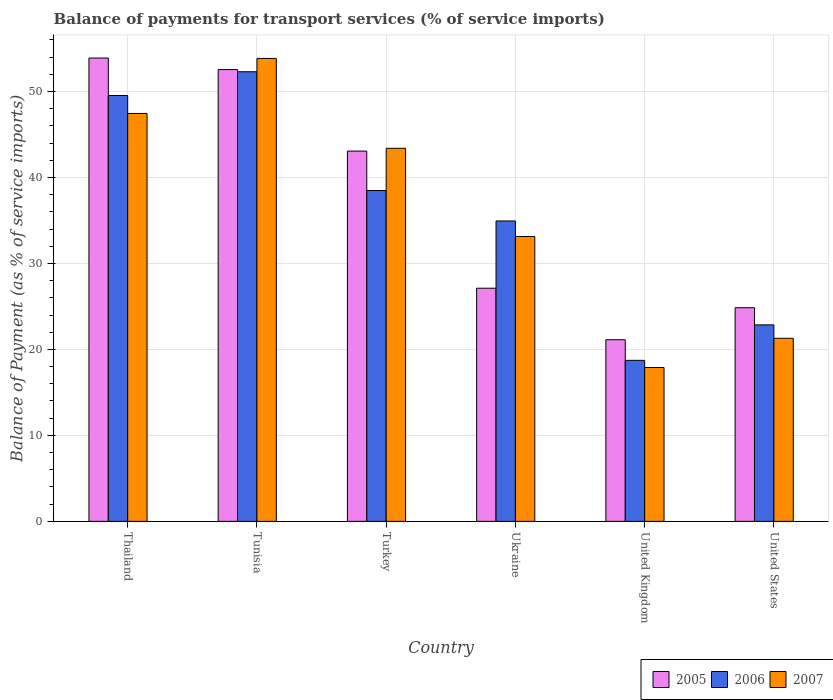How many different coloured bars are there?
Ensure brevity in your answer.  3. How many groups of bars are there?
Your response must be concise. 6. Are the number of bars per tick equal to the number of legend labels?
Your answer should be very brief. Yes. How many bars are there on the 3rd tick from the left?
Provide a short and direct response. 3. How many bars are there on the 6th tick from the right?
Your answer should be very brief. 3. What is the label of the 3rd group of bars from the left?
Your response must be concise. Turkey. In how many cases, is the number of bars for a given country not equal to the number of legend labels?
Your response must be concise. 0. What is the balance of payments for transport services in 2007 in United States?
Provide a short and direct response. 21.29. Across all countries, what is the maximum balance of payments for transport services in 2007?
Ensure brevity in your answer.  53.84. Across all countries, what is the minimum balance of payments for transport services in 2006?
Provide a short and direct response. 18.73. In which country was the balance of payments for transport services in 2006 maximum?
Your answer should be compact. Tunisia. In which country was the balance of payments for transport services in 2007 minimum?
Provide a short and direct response. United Kingdom. What is the total balance of payments for transport services in 2006 in the graph?
Your response must be concise. 216.81. What is the difference between the balance of payments for transport services in 2007 in Turkey and that in United States?
Ensure brevity in your answer.  22.1. What is the difference between the balance of payments for transport services in 2007 in Turkey and the balance of payments for transport services in 2006 in Ukraine?
Provide a short and direct response. 8.45. What is the average balance of payments for transport services in 2006 per country?
Ensure brevity in your answer.  36.13. What is the difference between the balance of payments for transport services of/in 2006 and balance of payments for transport services of/in 2005 in Ukraine?
Provide a succinct answer. 7.82. In how many countries, is the balance of payments for transport services in 2006 greater than 40 %?
Your answer should be very brief. 2. What is the ratio of the balance of payments for transport services in 2005 in Thailand to that in Turkey?
Provide a succinct answer. 1.25. Is the difference between the balance of payments for transport services in 2006 in Thailand and Ukraine greater than the difference between the balance of payments for transport services in 2005 in Thailand and Ukraine?
Your answer should be very brief. No. What is the difference between the highest and the second highest balance of payments for transport services in 2006?
Offer a terse response. -2.76. What is the difference between the highest and the lowest balance of payments for transport services in 2005?
Provide a succinct answer. 32.76. What does the 1st bar from the right in Thailand represents?
Your response must be concise. 2007. Is it the case that in every country, the sum of the balance of payments for transport services in 2005 and balance of payments for transport services in 2007 is greater than the balance of payments for transport services in 2006?
Provide a succinct answer. Yes. How many bars are there?
Ensure brevity in your answer.  18. Are all the bars in the graph horizontal?
Make the answer very short. No. Are the values on the major ticks of Y-axis written in scientific E-notation?
Give a very brief answer. No. How are the legend labels stacked?
Offer a very short reply. Horizontal. What is the title of the graph?
Offer a very short reply. Balance of payments for transport services (% of service imports). What is the label or title of the X-axis?
Provide a succinct answer. Country. What is the label or title of the Y-axis?
Offer a terse response. Balance of Payment (as % of service imports). What is the Balance of Payment (as % of service imports) of 2005 in Thailand?
Your response must be concise. 53.88. What is the Balance of Payment (as % of service imports) in 2006 in Thailand?
Give a very brief answer. 49.53. What is the Balance of Payment (as % of service imports) of 2007 in Thailand?
Make the answer very short. 47.44. What is the Balance of Payment (as % of service imports) of 2005 in Tunisia?
Provide a short and direct response. 52.54. What is the Balance of Payment (as % of service imports) of 2006 in Tunisia?
Provide a short and direct response. 52.29. What is the Balance of Payment (as % of service imports) of 2007 in Tunisia?
Make the answer very short. 53.84. What is the Balance of Payment (as % of service imports) of 2005 in Turkey?
Offer a very short reply. 43.06. What is the Balance of Payment (as % of service imports) of 2006 in Turkey?
Keep it short and to the point. 38.47. What is the Balance of Payment (as % of service imports) of 2007 in Turkey?
Your answer should be compact. 43.39. What is the Balance of Payment (as % of service imports) in 2005 in Ukraine?
Your response must be concise. 27.12. What is the Balance of Payment (as % of service imports) in 2006 in Ukraine?
Your answer should be very brief. 34.94. What is the Balance of Payment (as % of service imports) of 2007 in Ukraine?
Keep it short and to the point. 33.13. What is the Balance of Payment (as % of service imports) in 2005 in United Kingdom?
Offer a very short reply. 21.12. What is the Balance of Payment (as % of service imports) of 2006 in United Kingdom?
Your answer should be very brief. 18.73. What is the Balance of Payment (as % of service imports) in 2007 in United Kingdom?
Your response must be concise. 17.89. What is the Balance of Payment (as % of service imports) in 2005 in United States?
Your response must be concise. 24.85. What is the Balance of Payment (as % of service imports) in 2006 in United States?
Ensure brevity in your answer.  22.85. What is the Balance of Payment (as % of service imports) of 2007 in United States?
Keep it short and to the point. 21.29. Across all countries, what is the maximum Balance of Payment (as % of service imports) of 2005?
Make the answer very short. 53.88. Across all countries, what is the maximum Balance of Payment (as % of service imports) of 2006?
Your answer should be compact. 52.29. Across all countries, what is the maximum Balance of Payment (as % of service imports) of 2007?
Ensure brevity in your answer.  53.84. Across all countries, what is the minimum Balance of Payment (as % of service imports) in 2005?
Your answer should be compact. 21.12. Across all countries, what is the minimum Balance of Payment (as % of service imports) in 2006?
Your answer should be very brief. 18.73. Across all countries, what is the minimum Balance of Payment (as % of service imports) in 2007?
Provide a succinct answer. 17.89. What is the total Balance of Payment (as % of service imports) in 2005 in the graph?
Give a very brief answer. 222.57. What is the total Balance of Payment (as % of service imports) in 2006 in the graph?
Keep it short and to the point. 216.81. What is the total Balance of Payment (as % of service imports) in 2007 in the graph?
Your answer should be very brief. 216.99. What is the difference between the Balance of Payment (as % of service imports) of 2005 in Thailand and that in Tunisia?
Your response must be concise. 1.34. What is the difference between the Balance of Payment (as % of service imports) of 2006 in Thailand and that in Tunisia?
Ensure brevity in your answer.  -2.76. What is the difference between the Balance of Payment (as % of service imports) in 2007 in Thailand and that in Tunisia?
Your response must be concise. -6.4. What is the difference between the Balance of Payment (as % of service imports) of 2005 in Thailand and that in Turkey?
Provide a succinct answer. 10.82. What is the difference between the Balance of Payment (as % of service imports) in 2006 in Thailand and that in Turkey?
Your answer should be compact. 11.05. What is the difference between the Balance of Payment (as % of service imports) of 2007 in Thailand and that in Turkey?
Your answer should be compact. 4.05. What is the difference between the Balance of Payment (as % of service imports) of 2005 in Thailand and that in Ukraine?
Your answer should be compact. 26.77. What is the difference between the Balance of Payment (as % of service imports) of 2006 in Thailand and that in Ukraine?
Provide a succinct answer. 14.59. What is the difference between the Balance of Payment (as % of service imports) of 2007 in Thailand and that in Ukraine?
Your response must be concise. 14.31. What is the difference between the Balance of Payment (as % of service imports) in 2005 in Thailand and that in United Kingdom?
Your answer should be compact. 32.76. What is the difference between the Balance of Payment (as % of service imports) in 2006 in Thailand and that in United Kingdom?
Provide a succinct answer. 30.8. What is the difference between the Balance of Payment (as % of service imports) in 2007 in Thailand and that in United Kingdom?
Provide a succinct answer. 29.55. What is the difference between the Balance of Payment (as % of service imports) in 2005 in Thailand and that in United States?
Give a very brief answer. 29.04. What is the difference between the Balance of Payment (as % of service imports) in 2006 in Thailand and that in United States?
Offer a very short reply. 26.68. What is the difference between the Balance of Payment (as % of service imports) of 2007 in Thailand and that in United States?
Your response must be concise. 26.15. What is the difference between the Balance of Payment (as % of service imports) in 2005 in Tunisia and that in Turkey?
Provide a succinct answer. 9.48. What is the difference between the Balance of Payment (as % of service imports) of 2006 in Tunisia and that in Turkey?
Offer a very short reply. 13.82. What is the difference between the Balance of Payment (as % of service imports) of 2007 in Tunisia and that in Turkey?
Keep it short and to the point. 10.45. What is the difference between the Balance of Payment (as % of service imports) in 2005 in Tunisia and that in Ukraine?
Provide a short and direct response. 25.43. What is the difference between the Balance of Payment (as % of service imports) in 2006 in Tunisia and that in Ukraine?
Your answer should be very brief. 17.35. What is the difference between the Balance of Payment (as % of service imports) in 2007 in Tunisia and that in Ukraine?
Ensure brevity in your answer.  20.71. What is the difference between the Balance of Payment (as % of service imports) in 2005 in Tunisia and that in United Kingdom?
Provide a short and direct response. 31.42. What is the difference between the Balance of Payment (as % of service imports) in 2006 in Tunisia and that in United Kingdom?
Keep it short and to the point. 33.56. What is the difference between the Balance of Payment (as % of service imports) of 2007 in Tunisia and that in United Kingdom?
Provide a short and direct response. 35.95. What is the difference between the Balance of Payment (as % of service imports) in 2005 in Tunisia and that in United States?
Provide a short and direct response. 27.7. What is the difference between the Balance of Payment (as % of service imports) in 2006 in Tunisia and that in United States?
Provide a short and direct response. 29.44. What is the difference between the Balance of Payment (as % of service imports) in 2007 in Tunisia and that in United States?
Make the answer very short. 32.55. What is the difference between the Balance of Payment (as % of service imports) of 2005 in Turkey and that in Ukraine?
Offer a very short reply. 15.95. What is the difference between the Balance of Payment (as % of service imports) in 2006 in Turkey and that in Ukraine?
Offer a very short reply. 3.54. What is the difference between the Balance of Payment (as % of service imports) in 2007 in Turkey and that in Ukraine?
Your answer should be very brief. 10.26. What is the difference between the Balance of Payment (as % of service imports) in 2005 in Turkey and that in United Kingdom?
Your answer should be compact. 21.94. What is the difference between the Balance of Payment (as % of service imports) in 2006 in Turkey and that in United Kingdom?
Offer a very short reply. 19.75. What is the difference between the Balance of Payment (as % of service imports) of 2007 in Turkey and that in United Kingdom?
Keep it short and to the point. 25.49. What is the difference between the Balance of Payment (as % of service imports) in 2005 in Turkey and that in United States?
Offer a terse response. 18.22. What is the difference between the Balance of Payment (as % of service imports) of 2006 in Turkey and that in United States?
Keep it short and to the point. 15.62. What is the difference between the Balance of Payment (as % of service imports) of 2007 in Turkey and that in United States?
Ensure brevity in your answer.  22.1. What is the difference between the Balance of Payment (as % of service imports) of 2005 in Ukraine and that in United Kingdom?
Offer a terse response. 5.99. What is the difference between the Balance of Payment (as % of service imports) in 2006 in Ukraine and that in United Kingdom?
Make the answer very short. 16.21. What is the difference between the Balance of Payment (as % of service imports) of 2007 in Ukraine and that in United Kingdom?
Offer a very short reply. 15.24. What is the difference between the Balance of Payment (as % of service imports) in 2005 in Ukraine and that in United States?
Ensure brevity in your answer.  2.27. What is the difference between the Balance of Payment (as % of service imports) in 2006 in Ukraine and that in United States?
Ensure brevity in your answer.  12.09. What is the difference between the Balance of Payment (as % of service imports) of 2007 in Ukraine and that in United States?
Offer a terse response. 11.84. What is the difference between the Balance of Payment (as % of service imports) of 2005 in United Kingdom and that in United States?
Offer a very short reply. -3.72. What is the difference between the Balance of Payment (as % of service imports) in 2006 in United Kingdom and that in United States?
Offer a very short reply. -4.13. What is the difference between the Balance of Payment (as % of service imports) of 2007 in United Kingdom and that in United States?
Your answer should be compact. -3.4. What is the difference between the Balance of Payment (as % of service imports) of 2005 in Thailand and the Balance of Payment (as % of service imports) of 2006 in Tunisia?
Offer a terse response. 1.59. What is the difference between the Balance of Payment (as % of service imports) of 2005 in Thailand and the Balance of Payment (as % of service imports) of 2007 in Tunisia?
Make the answer very short. 0.04. What is the difference between the Balance of Payment (as % of service imports) in 2006 in Thailand and the Balance of Payment (as % of service imports) in 2007 in Tunisia?
Your answer should be compact. -4.31. What is the difference between the Balance of Payment (as % of service imports) in 2005 in Thailand and the Balance of Payment (as % of service imports) in 2006 in Turkey?
Keep it short and to the point. 15.41. What is the difference between the Balance of Payment (as % of service imports) in 2005 in Thailand and the Balance of Payment (as % of service imports) in 2007 in Turkey?
Make the answer very short. 10.5. What is the difference between the Balance of Payment (as % of service imports) of 2006 in Thailand and the Balance of Payment (as % of service imports) of 2007 in Turkey?
Provide a short and direct response. 6.14. What is the difference between the Balance of Payment (as % of service imports) in 2005 in Thailand and the Balance of Payment (as % of service imports) in 2006 in Ukraine?
Offer a very short reply. 18.95. What is the difference between the Balance of Payment (as % of service imports) of 2005 in Thailand and the Balance of Payment (as % of service imports) of 2007 in Ukraine?
Provide a succinct answer. 20.75. What is the difference between the Balance of Payment (as % of service imports) of 2006 in Thailand and the Balance of Payment (as % of service imports) of 2007 in Ukraine?
Provide a short and direct response. 16.4. What is the difference between the Balance of Payment (as % of service imports) in 2005 in Thailand and the Balance of Payment (as % of service imports) in 2006 in United Kingdom?
Provide a short and direct response. 35.16. What is the difference between the Balance of Payment (as % of service imports) in 2005 in Thailand and the Balance of Payment (as % of service imports) in 2007 in United Kingdom?
Keep it short and to the point. 35.99. What is the difference between the Balance of Payment (as % of service imports) of 2006 in Thailand and the Balance of Payment (as % of service imports) of 2007 in United Kingdom?
Give a very brief answer. 31.63. What is the difference between the Balance of Payment (as % of service imports) in 2005 in Thailand and the Balance of Payment (as % of service imports) in 2006 in United States?
Provide a succinct answer. 31.03. What is the difference between the Balance of Payment (as % of service imports) in 2005 in Thailand and the Balance of Payment (as % of service imports) in 2007 in United States?
Your answer should be compact. 32.59. What is the difference between the Balance of Payment (as % of service imports) of 2006 in Thailand and the Balance of Payment (as % of service imports) of 2007 in United States?
Provide a short and direct response. 28.24. What is the difference between the Balance of Payment (as % of service imports) in 2005 in Tunisia and the Balance of Payment (as % of service imports) in 2006 in Turkey?
Offer a very short reply. 14.07. What is the difference between the Balance of Payment (as % of service imports) of 2005 in Tunisia and the Balance of Payment (as % of service imports) of 2007 in Turkey?
Your answer should be compact. 9.16. What is the difference between the Balance of Payment (as % of service imports) in 2006 in Tunisia and the Balance of Payment (as % of service imports) in 2007 in Turkey?
Provide a short and direct response. 8.9. What is the difference between the Balance of Payment (as % of service imports) in 2005 in Tunisia and the Balance of Payment (as % of service imports) in 2006 in Ukraine?
Give a very brief answer. 17.61. What is the difference between the Balance of Payment (as % of service imports) of 2005 in Tunisia and the Balance of Payment (as % of service imports) of 2007 in Ukraine?
Your answer should be very brief. 19.41. What is the difference between the Balance of Payment (as % of service imports) in 2006 in Tunisia and the Balance of Payment (as % of service imports) in 2007 in Ukraine?
Provide a succinct answer. 19.16. What is the difference between the Balance of Payment (as % of service imports) in 2005 in Tunisia and the Balance of Payment (as % of service imports) in 2006 in United Kingdom?
Provide a short and direct response. 33.82. What is the difference between the Balance of Payment (as % of service imports) in 2005 in Tunisia and the Balance of Payment (as % of service imports) in 2007 in United Kingdom?
Your answer should be very brief. 34.65. What is the difference between the Balance of Payment (as % of service imports) in 2006 in Tunisia and the Balance of Payment (as % of service imports) in 2007 in United Kingdom?
Your answer should be very brief. 34.4. What is the difference between the Balance of Payment (as % of service imports) of 2005 in Tunisia and the Balance of Payment (as % of service imports) of 2006 in United States?
Give a very brief answer. 29.69. What is the difference between the Balance of Payment (as % of service imports) in 2005 in Tunisia and the Balance of Payment (as % of service imports) in 2007 in United States?
Your answer should be very brief. 31.25. What is the difference between the Balance of Payment (as % of service imports) of 2006 in Tunisia and the Balance of Payment (as % of service imports) of 2007 in United States?
Your answer should be very brief. 31. What is the difference between the Balance of Payment (as % of service imports) in 2005 in Turkey and the Balance of Payment (as % of service imports) in 2006 in Ukraine?
Make the answer very short. 8.13. What is the difference between the Balance of Payment (as % of service imports) of 2005 in Turkey and the Balance of Payment (as % of service imports) of 2007 in Ukraine?
Ensure brevity in your answer.  9.93. What is the difference between the Balance of Payment (as % of service imports) in 2006 in Turkey and the Balance of Payment (as % of service imports) in 2007 in Ukraine?
Your response must be concise. 5.34. What is the difference between the Balance of Payment (as % of service imports) of 2005 in Turkey and the Balance of Payment (as % of service imports) of 2006 in United Kingdom?
Your answer should be compact. 24.34. What is the difference between the Balance of Payment (as % of service imports) of 2005 in Turkey and the Balance of Payment (as % of service imports) of 2007 in United Kingdom?
Ensure brevity in your answer.  25.17. What is the difference between the Balance of Payment (as % of service imports) in 2006 in Turkey and the Balance of Payment (as % of service imports) in 2007 in United Kingdom?
Make the answer very short. 20.58. What is the difference between the Balance of Payment (as % of service imports) of 2005 in Turkey and the Balance of Payment (as % of service imports) of 2006 in United States?
Offer a terse response. 20.21. What is the difference between the Balance of Payment (as % of service imports) of 2005 in Turkey and the Balance of Payment (as % of service imports) of 2007 in United States?
Keep it short and to the point. 21.77. What is the difference between the Balance of Payment (as % of service imports) of 2006 in Turkey and the Balance of Payment (as % of service imports) of 2007 in United States?
Offer a terse response. 17.18. What is the difference between the Balance of Payment (as % of service imports) of 2005 in Ukraine and the Balance of Payment (as % of service imports) of 2006 in United Kingdom?
Provide a succinct answer. 8.39. What is the difference between the Balance of Payment (as % of service imports) in 2005 in Ukraine and the Balance of Payment (as % of service imports) in 2007 in United Kingdom?
Make the answer very short. 9.22. What is the difference between the Balance of Payment (as % of service imports) of 2006 in Ukraine and the Balance of Payment (as % of service imports) of 2007 in United Kingdom?
Provide a succinct answer. 17.04. What is the difference between the Balance of Payment (as % of service imports) of 2005 in Ukraine and the Balance of Payment (as % of service imports) of 2006 in United States?
Ensure brevity in your answer.  4.26. What is the difference between the Balance of Payment (as % of service imports) of 2005 in Ukraine and the Balance of Payment (as % of service imports) of 2007 in United States?
Provide a succinct answer. 5.82. What is the difference between the Balance of Payment (as % of service imports) of 2006 in Ukraine and the Balance of Payment (as % of service imports) of 2007 in United States?
Ensure brevity in your answer.  13.65. What is the difference between the Balance of Payment (as % of service imports) of 2005 in United Kingdom and the Balance of Payment (as % of service imports) of 2006 in United States?
Provide a succinct answer. -1.73. What is the difference between the Balance of Payment (as % of service imports) of 2005 in United Kingdom and the Balance of Payment (as % of service imports) of 2007 in United States?
Make the answer very short. -0.17. What is the difference between the Balance of Payment (as % of service imports) of 2006 in United Kingdom and the Balance of Payment (as % of service imports) of 2007 in United States?
Your answer should be compact. -2.57. What is the average Balance of Payment (as % of service imports) in 2005 per country?
Ensure brevity in your answer.  37.1. What is the average Balance of Payment (as % of service imports) in 2006 per country?
Offer a terse response. 36.13. What is the average Balance of Payment (as % of service imports) of 2007 per country?
Ensure brevity in your answer.  36.16. What is the difference between the Balance of Payment (as % of service imports) in 2005 and Balance of Payment (as % of service imports) in 2006 in Thailand?
Provide a short and direct response. 4.36. What is the difference between the Balance of Payment (as % of service imports) of 2005 and Balance of Payment (as % of service imports) of 2007 in Thailand?
Your response must be concise. 6.44. What is the difference between the Balance of Payment (as % of service imports) of 2006 and Balance of Payment (as % of service imports) of 2007 in Thailand?
Your response must be concise. 2.09. What is the difference between the Balance of Payment (as % of service imports) in 2005 and Balance of Payment (as % of service imports) in 2006 in Tunisia?
Offer a terse response. 0.25. What is the difference between the Balance of Payment (as % of service imports) in 2005 and Balance of Payment (as % of service imports) in 2007 in Tunisia?
Make the answer very short. -1.3. What is the difference between the Balance of Payment (as % of service imports) of 2006 and Balance of Payment (as % of service imports) of 2007 in Tunisia?
Your answer should be very brief. -1.55. What is the difference between the Balance of Payment (as % of service imports) in 2005 and Balance of Payment (as % of service imports) in 2006 in Turkey?
Make the answer very short. 4.59. What is the difference between the Balance of Payment (as % of service imports) of 2005 and Balance of Payment (as % of service imports) of 2007 in Turkey?
Provide a short and direct response. -0.33. What is the difference between the Balance of Payment (as % of service imports) in 2006 and Balance of Payment (as % of service imports) in 2007 in Turkey?
Your answer should be compact. -4.91. What is the difference between the Balance of Payment (as % of service imports) in 2005 and Balance of Payment (as % of service imports) in 2006 in Ukraine?
Your response must be concise. -7.82. What is the difference between the Balance of Payment (as % of service imports) of 2005 and Balance of Payment (as % of service imports) of 2007 in Ukraine?
Give a very brief answer. -6.01. What is the difference between the Balance of Payment (as % of service imports) in 2006 and Balance of Payment (as % of service imports) in 2007 in Ukraine?
Ensure brevity in your answer.  1.81. What is the difference between the Balance of Payment (as % of service imports) of 2005 and Balance of Payment (as % of service imports) of 2006 in United Kingdom?
Offer a very short reply. 2.4. What is the difference between the Balance of Payment (as % of service imports) in 2005 and Balance of Payment (as % of service imports) in 2007 in United Kingdom?
Make the answer very short. 3.23. What is the difference between the Balance of Payment (as % of service imports) in 2006 and Balance of Payment (as % of service imports) in 2007 in United Kingdom?
Ensure brevity in your answer.  0.83. What is the difference between the Balance of Payment (as % of service imports) of 2005 and Balance of Payment (as % of service imports) of 2006 in United States?
Offer a terse response. 2. What is the difference between the Balance of Payment (as % of service imports) in 2005 and Balance of Payment (as % of service imports) in 2007 in United States?
Ensure brevity in your answer.  3.55. What is the difference between the Balance of Payment (as % of service imports) of 2006 and Balance of Payment (as % of service imports) of 2007 in United States?
Offer a very short reply. 1.56. What is the ratio of the Balance of Payment (as % of service imports) of 2005 in Thailand to that in Tunisia?
Ensure brevity in your answer.  1.03. What is the ratio of the Balance of Payment (as % of service imports) in 2006 in Thailand to that in Tunisia?
Provide a succinct answer. 0.95. What is the ratio of the Balance of Payment (as % of service imports) in 2007 in Thailand to that in Tunisia?
Give a very brief answer. 0.88. What is the ratio of the Balance of Payment (as % of service imports) in 2005 in Thailand to that in Turkey?
Your answer should be compact. 1.25. What is the ratio of the Balance of Payment (as % of service imports) in 2006 in Thailand to that in Turkey?
Your answer should be compact. 1.29. What is the ratio of the Balance of Payment (as % of service imports) of 2007 in Thailand to that in Turkey?
Provide a succinct answer. 1.09. What is the ratio of the Balance of Payment (as % of service imports) of 2005 in Thailand to that in Ukraine?
Your answer should be compact. 1.99. What is the ratio of the Balance of Payment (as % of service imports) in 2006 in Thailand to that in Ukraine?
Give a very brief answer. 1.42. What is the ratio of the Balance of Payment (as % of service imports) of 2007 in Thailand to that in Ukraine?
Keep it short and to the point. 1.43. What is the ratio of the Balance of Payment (as % of service imports) of 2005 in Thailand to that in United Kingdom?
Your answer should be very brief. 2.55. What is the ratio of the Balance of Payment (as % of service imports) in 2006 in Thailand to that in United Kingdom?
Your answer should be very brief. 2.65. What is the ratio of the Balance of Payment (as % of service imports) in 2007 in Thailand to that in United Kingdom?
Your answer should be compact. 2.65. What is the ratio of the Balance of Payment (as % of service imports) in 2005 in Thailand to that in United States?
Your answer should be compact. 2.17. What is the ratio of the Balance of Payment (as % of service imports) in 2006 in Thailand to that in United States?
Your answer should be very brief. 2.17. What is the ratio of the Balance of Payment (as % of service imports) in 2007 in Thailand to that in United States?
Your response must be concise. 2.23. What is the ratio of the Balance of Payment (as % of service imports) of 2005 in Tunisia to that in Turkey?
Your answer should be very brief. 1.22. What is the ratio of the Balance of Payment (as % of service imports) of 2006 in Tunisia to that in Turkey?
Provide a short and direct response. 1.36. What is the ratio of the Balance of Payment (as % of service imports) in 2007 in Tunisia to that in Turkey?
Offer a very short reply. 1.24. What is the ratio of the Balance of Payment (as % of service imports) of 2005 in Tunisia to that in Ukraine?
Offer a terse response. 1.94. What is the ratio of the Balance of Payment (as % of service imports) in 2006 in Tunisia to that in Ukraine?
Offer a very short reply. 1.5. What is the ratio of the Balance of Payment (as % of service imports) of 2007 in Tunisia to that in Ukraine?
Your response must be concise. 1.63. What is the ratio of the Balance of Payment (as % of service imports) of 2005 in Tunisia to that in United Kingdom?
Your response must be concise. 2.49. What is the ratio of the Balance of Payment (as % of service imports) of 2006 in Tunisia to that in United Kingdom?
Provide a succinct answer. 2.79. What is the ratio of the Balance of Payment (as % of service imports) in 2007 in Tunisia to that in United Kingdom?
Your answer should be compact. 3.01. What is the ratio of the Balance of Payment (as % of service imports) in 2005 in Tunisia to that in United States?
Give a very brief answer. 2.11. What is the ratio of the Balance of Payment (as % of service imports) in 2006 in Tunisia to that in United States?
Keep it short and to the point. 2.29. What is the ratio of the Balance of Payment (as % of service imports) of 2007 in Tunisia to that in United States?
Give a very brief answer. 2.53. What is the ratio of the Balance of Payment (as % of service imports) in 2005 in Turkey to that in Ukraine?
Your answer should be very brief. 1.59. What is the ratio of the Balance of Payment (as % of service imports) of 2006 in Turkey to that in Ukraine?
Make the answer very short. 1.1. What is the ratio of the Balance of Payment (as % of service imports) of 2007 in Turkey to that in Ukraine?
Keep it short and to the point. 1.31. What is the ratio of the Balance of Payment (as % of service imports) in 2005 in Turkey to that in United Kingdom?
Ensure brevity in your answer.  2.04. What is the ratio of the Balance of Payment (as % of service imports) in 2006 in Turkey to that in United Kingdom?
Your answer should be very brief. 2.05. What is the ratio of the Balance of Payment (as % of service imports) in 2007 in Turkey to that in United Kingdom?
Your answer should be very brief. 2.42. What is the ratio of the Balance of Payment (as % of service imports) in 2005 in Turkey to that in United States?
Ensure brevity in your answer.  1.73. What is the ratio of the Balance of Payment (as % of service imports) of 2006 in Turkey to that in United States?
Your answer should be compact. 1.68. What is the ratio of the Balance of Payment (as % of service imports) in 2007 in Turkey to that in United States?
Make the answer very short. 2.04. What is the ratio of the Balance of Payment (as % of service imports) in 2005 in Ukraine to that in United Kingdom?
Keep it short and to the point. 1.28. What is the ratio of the Balance of Payment (as % of service imports) in 2006 in Ukraine to that in United Kingdom?
Give a very brief answer. 1.87. What is the ratio of the Balance of Payment (as % of service imports) in 2007 in Ukraine to that in United Kingdom?
Ensure brevity in your answer.  1.85. What is the ratio of the Balance of Payment (as % of service imports) of 2005 in Ukraine to that in United States?
Offer a very short reply. 1.09. What is the ratio of the Balance of Payment (as % of service imports) in 2006 in Ukraine to that in United States?
Keep it short and to the point. 1.53. What is the ratio of the Balance of Payment (as % of service imports) in 2007 in Ukraine to that in United States?
Provide a short and direct response. 1.56. What is the ratio of the Balance of Payment (as % of service imports) in 2005 in United Kingdom to that in United States?
Your answer should be very brief. 0.85. What is the ratio of the Balance of Payment (as % of service imports) in 2006 in United Kingdom to that in United States?
Your answer should be very brief. 0.82. What is the ratio of the Balance of Payment (as % of service imports) in 2007 in United Kingdom to that in United States?
Your answer should be compact. 0.84. What is the difference between the highest and the second highest Balance of Payment (as % of service imports) of 2005?
Give a very brief answer. 1.34. What is the difference between the highest and the second highest Balance of Payment (as % of service imports) of 2006?
Ensure brevity in your answer.  2.76. What is the difference between the highest and the second highest Balance of Payment (as % of service imports) in 2007?
Offer a terse response. 6.4. What is the difference between the highest and the lowest Balance of Payment (as % of service imports) in 2005?
Give a very brief answer. 32.76. What is the difference between the highest and the lowest Balance of Payment (as % of service imports) of 2006?
Your answer should be compact. 33.56. What is the difference between the highest and the lowest Balance of Payment (as % of service imports) in 2007?
Offer a very short reply. 35.95. 